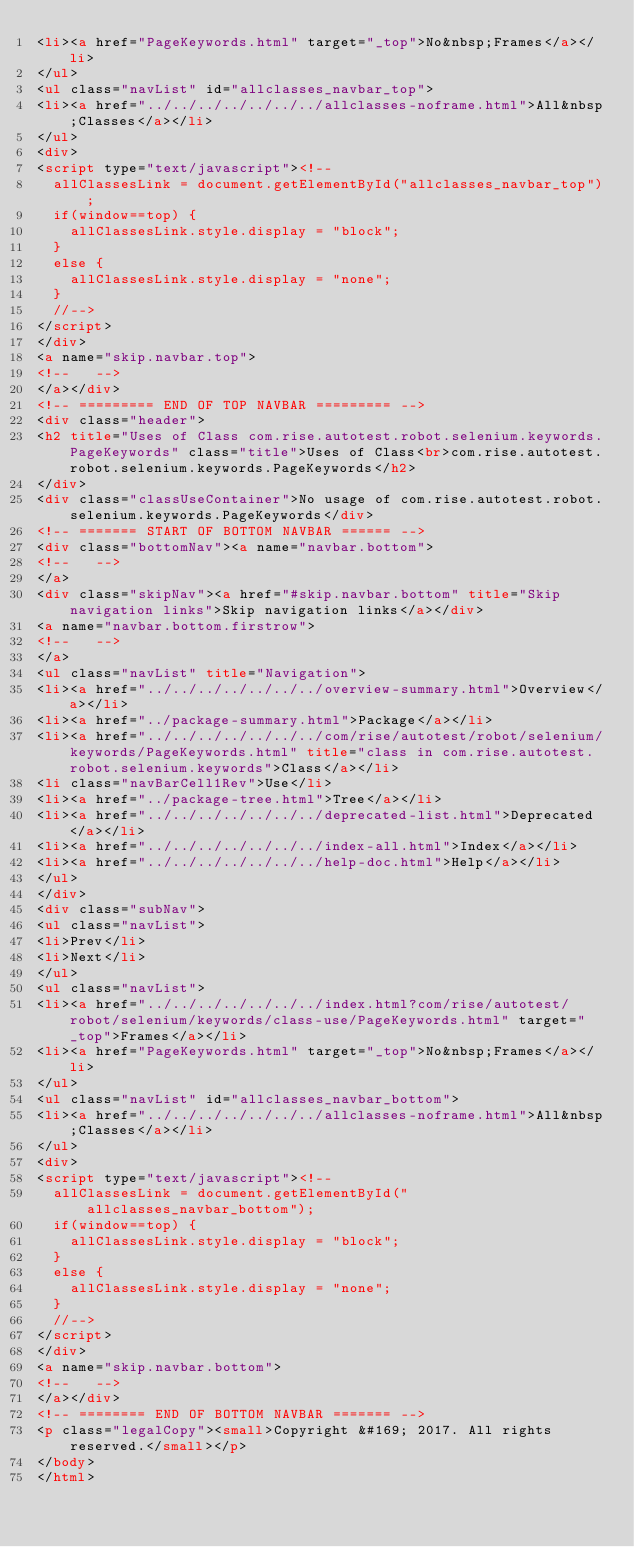<code> <loc_0><loc_0><loc_500><loc_500><_HTML_><li><a href="PageKeywords.html" target="_top">No&nbsp;Frames</a></li>
</ul>
<ul class="navList" id="allclasses_navbar_top">
<li><a href="../../../../../../../allclasses-noframe.html">All&nbsp;Classes</a></li>
</ul>
<div>
<script type="text/javascript"><!--
  allClassesLink = document.getElementById("allclasses_navbar_top");
  if(window==top) {
    allClassesLink.style.display = "block";
  }
  else {
    allClassesLink.style.display = "none";
  }
  //-->
</script>
</div>
<a name="skip.navbar.top">
<!--   -->
</a></div>
<!-- ========= END OF TOP NAVBAR ========= -->
<div class="header">
<h2 title="Uses of Class com.rise.autotest.robot.selenium.keywords.PageKeywords" class="title">Uses of Class<br>com.rise.autotest.robot.selenium.keywords.PageKeywords</h2>
</div>
<div class="classUseContainer">No usage of com.rise.autotest.robot.selenium.keywords.PageKeywords</div>
<!-- ======= START OF BOTTOM NAVBAR ====== -->
<div class="bottomNav"><a name="navbar.bottom">
<!--   -->
</a>
<div class="skipNav"><a href="#skip.navbar.bottom" title="Skip navigation links">Skip navigation links</a></div>
<a name="navbar.bottom.firstrow">
<!--   -->
</a>
<ul class="navList" title="Navigation">
<li><a href="../../../../../../../overview-summary.html">Overview</a></li>
<li><a href="../package-summary.html">Package</a></li>
<li><a href="../../../../../../../com/rise/autotest/robot/selenium/keywords/PageKeywords.html" title="class in com.rise.autotest.robot.selenium.keywords">Class</a></li>
<li class="navBarCell1Rev">Use</li>
<li><a href="../package-tree.html">Tree</a></li>
<li><a href="../../../../../../../deprecated-list.html">Deprecated</a></li>
<li><a href="../../../../../../../index-all.html">Index</a></li>
<li><a href="../../../../../../../help-doc.html">Help</a></li>
</ul>
</div>
<div class="subNav">
<ul class="navList">
<li>Prev</li>
<li>Next</li>
</ul>
<ul class="navList">
<li><a href="../../../../../../../index.html?com/rise/autotest/robot/selenium/keywords/class-use/PageKeywords.html" target="_top">Frames</a></li>
<li><a href="PageKeywords.html" target="_top">No&nbsp;Frames</a></li>
</ul>
<ul class="navList" id="allclasses_navbar_bottom">
<li><a href="../../../../../../../allclasses-noframe.html">All&nbsp;Classes</a></li>
</ul>
<div>
<script type="text/javascript"><!--
  allClassesLink = document.getElementById("allclasses_navbar_bottom");
  if(window==top) {
    allClassesLink.style.display = "block";
  }
  else {
    allClassesLink.style.display = "none";
  }
  //-->
</script>
</div>
<a name="skip.navbar.bottom">
<!--   -->
</a></div>
<!-- ======== END OF BOTTOM NAVBAR ======= -->
<p class="legalCopy"><small>Copyright &#169; 2017. All rights reserved.</small></p>
</body>
</html>
</code> 